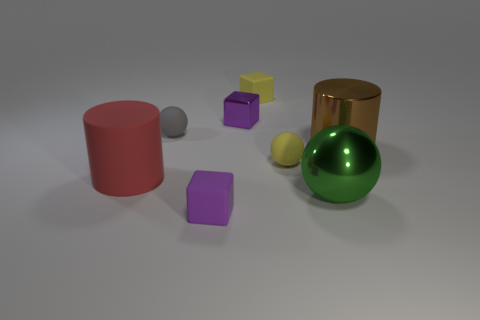What is the color of the rubber cube behind the big shiny cylinder?
Your answer should be very brief. Yellow. Is there a gray sphere in front of the cube in front of the purple metal cube?
Your answer should be compact. No. There is a small gray rubber thing; does it have the same shape as the shiny thing that is left of the large green object?
Keep it short and to the point. No. There is a metallic object that is both behind the red matte object and right of the metallic block; what size is it?
Ensure brevity in your answer.  Large. Is there a big purple thing that has the same material as the green object?
Make the answer very short. No. The matte cube that is the same color as the metal block is what size?
Your answer should be compact. Small. What material is the tiny yellow cube right of the small thing in front of the yellow ball made of?
Make the answer very short. Rubber. How many big shiny balls have the same color as the shiny cylinder?
Provide a short and direct response. 0. There is a purple object that is the same material as the green ball; what size is it?
Your response must be concise. Small. There is a tiny yellow matte object in front of the big shiny cylinder; what shape is it?
Keep it short and to the point. Sphere. 